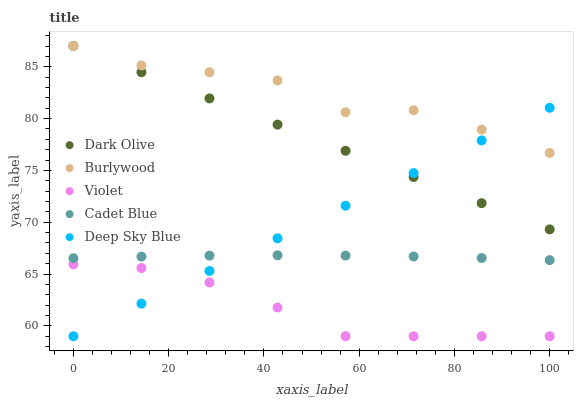Does Violet have the minimum area under the curve?
Answer yes or no. Yes. Does Burlywood have the maximum area under the curve?
Answer yes or no. Yes. Does Dark Olive have the minimum area under the curve?
Answer yes or no. No. Does Dark Olive have the maximum area under the curve?
Answer yes or no. No. Is Deep Sky Blue the smoothest?
Answer yes or no. Yes. Is Burlywood the roughest?
Answer yes or no. Yes. Is Dark Olive the smoothest?
Answer yes or no. No. Is Dark Olive the roughest?
Answer yes or no. No. Does Deep Sky Blue have the lowest value?
Answer yes or no. Yes. Does Dark Olive have the lowest value?
Answer yes or no. No. Does Dark Olive have the highest value?
Answer yes or no. Yes. Does Cadet Blue have the highest value?
Answer yes or no. No. Is Violet less than Burlywood?
Answer yes or no. Yes. Is Dark Olive greater than Cadet Blue?
Answer yes or no. Yes. Does Burlywood intersect Deep Sky Blue?
Answer yes or no. Yes. Is Burlywood less than Deep Sky Blue?
Answer yes or no. No. Is Burlywood greater than Deep Sky Blue?
Answer yes or no. No. Does Violet intersect Burlywood?
Answer yes or no. No. 